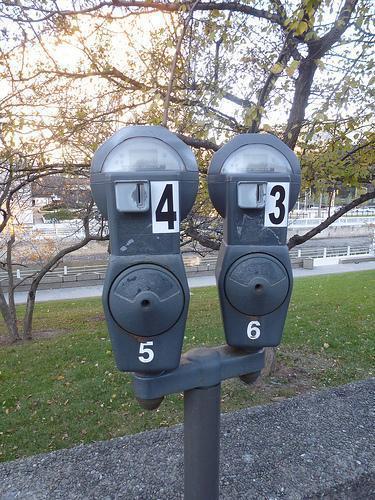How many parking meters are on a pole?
Give a very brief answer. 2. 